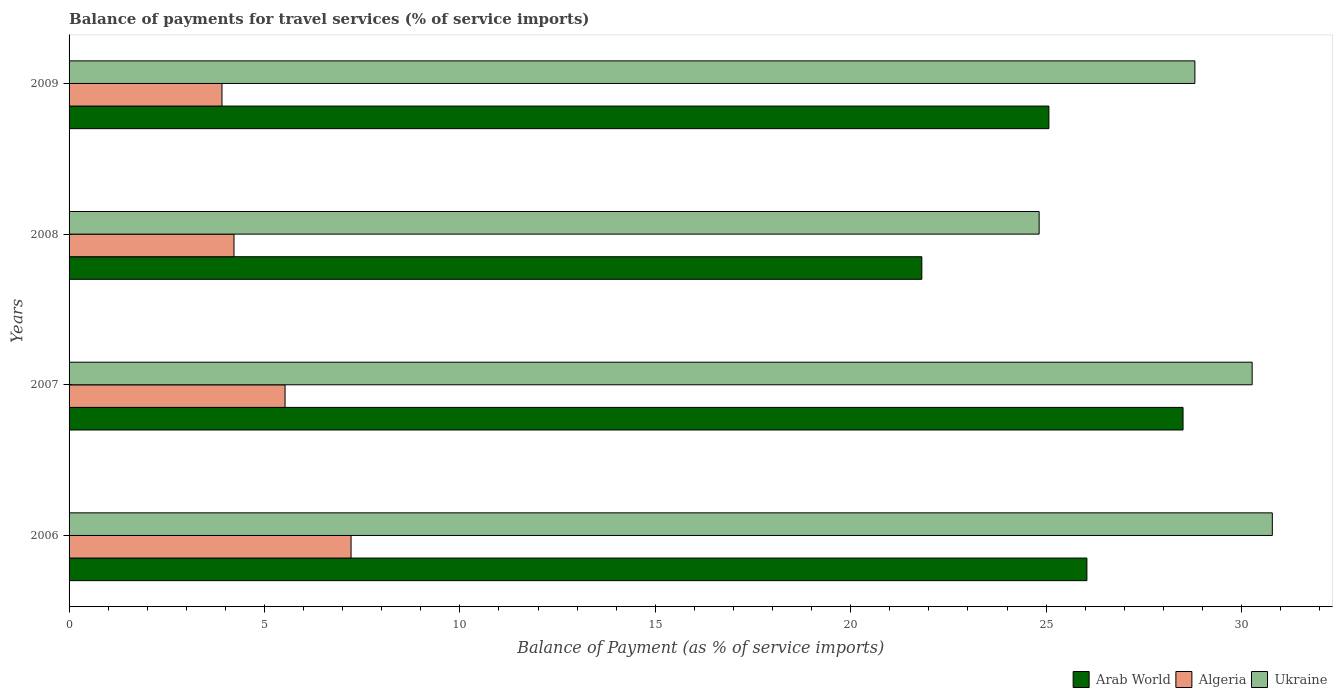How many different coloured bars are there?
Give a very brief answer. 3. How many groups of bars are there?
Provide a short and direct response. 4. Are the number of bars per tick equal to the number of legend labels?
Keep it short and to the point. Yes. How many bars are there on the 2nd tick from the top?
Provide a succinct answer. 3. How many bars are there on the 4th tick from the bottom?
Provide a succinct answer. 3. What is the label of the 2nd group of bars from the top?
Provide a short and direct response. 2008. In how many cases, is the number of bars for a given year not equal to the number of legend labels?
Keep it short and to the point. 0. What is the balance of payments for travel services in Ukraine in 2009?
Make the answer very short. 28.81. Across all years, what is the maximum balance of payments for travel services in Ukraine?
Give a very brief answer. 30.79. Across all years, what is the minimum balance of payments for travel services in Algeria?
Offer a very short reply. 3.91. In which year was the balance of payments for travel services in Algeria minimum?
Offer a very short reply. 2009. What is the total balance of payments for travel services in Ukraine in the graph?
Your answer should be very brief. 114.69. What is the difference between the balance of payments for travel services in Algeria in 2008 and that in 2009?
Your answer should be compact. 0.31. What is the difference between the balance of payments for travel services in Ukraine in 2009 and the balance of payments for travel services in Algeria in 2008?
Make the answer very short. 24.59. What is the average balance of payments for travel services in Ukraine per year?
Ensure brevity in your answer.  28.67. In the year 2006, what is the difference between the balance of payments for travel services in Ukraine and balance of payments for travel services in Arab World?
Offer a terse response. 4.74. What is the ratio of the balance of payments for travel services in Arab World in 2006 to that in 2007?
Provide a succinct answer. 0.91. Is the balance of payments for travel services in Ukraine in 2007 less than that in 2009?
Provide a succinct answer. No. What is the difference between the highest and the second highest balance of payments for travel services in Arab World?
Offer a very short reply. 2.46. What is the difference between the highest and the lowest balance of payments for travel services in Ukraine?
Offer a very short reply. 5.97. What does the 1st bar from the top in 2006 represents?
Your response must be concise. Ukraine. What does the 1st bar from the bottom in 2009 represents?
Your answer should be very brief. Arab World. Is it the case that in every year, the sum of the balance of payments for travel services in Arab World and balance of payments for travel services in Algeria is greater than the balance of payments for travel services in Ukraine?
Keep it short and to the point. Yes. How many bars are there?
Keep it short and to the point. 12. Are all the bars in the graph horizontal?
Ensure brevity in your answer.  Yes. Are the values on the major ticks of X-axis written in scientific E-notation?
Make the answer very short. No. Does the graph contain any zero values?
Your answer should be very brief. No. Does the graph contain grids?
Provide a succinct answer. No. Where does the legend appear in the graph?
Your answer should be compact. Bottom right. How many legend labels are there?
Offer a very short reply. 3. How are the legend labels stacked?
Provide a short and direct response. Horizontal. What is the title of the graph?
Make the answer very short. Balance of payments for travel services (% of service imports). What is the label or title of the X-axis?
Provide a succinct answer. Balance of Payment (as % of service imports). What is the Balance of Payment (as % of service imports) in Arab World in 2006?
Make the answer very short. 26.04. What is the Balance of Payment (as % of service imports) in Algeria in 2006?
Offer a very short reply. 7.22. What is the Balance of Payment (as % of service imports) of Ukraine in 2006?
Offer a very short reply. 30.79. What is the Balance of Payment (as % of service imports) of Arab World in 2007?
Your answer should be very brief. 28.5. What is the Balance of Payment (as % of service imports) in Algeria in 2007?
Make the answer very short. 5.53. What is the Balance of Payment (as % of service imports) in Ukraine in 2007?
Ensure brevity in your answer.  30.27. What is the Balance of Payment (as % of service imports) in Arab World in 2008?
Ensure brevity in your answer.  21.82. What is the Balance of Payment (as % of service imports) in Algeria in 2008?
Provide a short and direct response. 4.22. What is the Balance of Payment (as % of service imports) of Ukraine in 2008?
Provide a succinct answer. 24.82. What is the Balance of Payment (as % of service imports) in Arab World in 2009?
Ensure brevity in your answer.  25.07. What is the Balance of Payment (as % of service imports) in Algeria in 2009?
Your answer should be compact. 3.91. What is the Balance of Payment (as % of service imports) in Ukraine in 2009?
Give a very brief answer. 28.81. Across all years, what is the maximum Balance of Payment (as % of service imports) of Arab World?
Keep it short and to the point. 28.5. Across all years, what is the maximum Balance of Payment (as % of service imports) of Algeria?
Your response must be concise. 7.22. Across all years, what is the maximum Balance of Payment (as % of service imports) of Ukraine?
Ensure brevity in your answer.  30.79. Across all years, what is the minimum Balance of Payment (as % of service imports) in Arab World?
Offer a terse response. 21.82. Across all years, what is the minimum Balance of Payment (as % of service imports) in Algeria?
Your answer should be compact. 3.91. Across all years, what is the minimum Balance of Payment (as % of service imports) in Ukraine?
Your answer should be compact. 24.82. What is the total Balance of Payment (as % of service imports) of Arab World in the graph?
Keep it short and to the point. 101.44. What is the total Balance of Payment (as % of service imports) in Algeria in the graph?
Provide a short and direct response. 20.87. What is the total Balance of Payment (as % of service imports) in Ukraine in the graph?
Give a very brief answer. 114.69. What is the difference between the Balance of Payment (as % of service imports) in Arab World in 2006 and that in 2007?
Your answer should be compact. -2.46. What is the difference between the Balance of Payment (as % of service imports) of Algeria in 2006 and that in 2007?
Make the answer very short. 1.69. What is the difference between the Balance of Payment (as % of service imports) in Ukraine in 2006 and that in 2007?
Your answer should be compact. 0.52. What is the difference between the Balance of Payment (as % of service imports) of Arab World in 2006 and that in 2008?
Ensure brevity in your answer.  4.22. What is the difference between the Balance of Payment (as % of service imports) in Algeria in 2006 and that in 2008?
Provide a short and direct response. 3. What is the difference between the Balance of Payment (as % of service imports) of Ukraine in 2006 and that in 2008?
Offer a terse response. 5.97. What is the difference between the Balance of Payment (as % of service imports) of Arab World in 2006 and that in 2009?
Make the answer very short. 0.97. What is the difference between the Balance of Payment (as % of service imports) in Algeria in 2006 and that in 2009?
Your response must be concise. 3.3. What is the difference between the Balance of Payment (as % of service imports) in Ukraine in 2006 and that in 2009?
Provide a short and direct response. 1.98. What is the difference between the Balance of Payment (as % of service imports) of Arab World in 2007 and that in 2008?
Your answer should be very brief. 6.68. What is the difference between the Balance of Payment (as % of service imports) of Algeria in 2007 and that in 2008?
Ensure brevity in your answer.  1.31. What is the difference between the Balance of Payment (as % of service imports) of Ukraine in 2007 and that in 2008?
Give a very brief answer. 5.45. What is the difference between the Balance of Payment (as % of service imports) in Arab World in 2007 and that in 2009?
Offer a very short reply. 3.43. What is the difference between the Balance of Payment (as % of service imports) of Algeria in 2007 and that in 2009?
Offer a very short reply. 1.61. What is the difference between the Balance of Payment (as % of service imports) of Ukraine in 2007 and that in 2009?
Your answer should be very brief. 1.47. What is the difference between the Balance of Payment (as % of service imports) in Arab World in 2008 and that in 2009?
Offer a very short reply. -3.25. What is the difference between the Balance of Payment (as % of service imports) in Algeria in 2008 and that in 2009?
Make the answer very short. 0.31. What is the difference between the Balance of Payment (as % of service imports) in Ukraine in 2008 and that in 2009?
Give a very brief answer. -3.99. What is the difference between the Balance of Payment (as % of service imports) in Arab World in 2006 and the Balance of Payment (as % of service imports) in Algeria in 2007?
Offer a terse response. 20.52. What is the difference between the Balance of Payment (as % of service imports) of Arab World in 2006 and the Balance of Payment (as % of service imports) of Ukraine in 2007?
Offer a very short reply. -4.23. What is the difference between the Balance of Payment (as % of service imports) in Algeria in 2006 and the Balance of Payment (as % of service imports) in Ukraine in 2007?
Your response must be concise. -23.06. What is the difference between the Balance of Payment (as % of service imports) of Arab World in 2006 and the Balance of Payment (as % of service imports) of Algeria in 2008?
Ensure brevity in your answer.  21.82. What is the difference between the Balance of Payment (as % of service imports) of Arab World in 2006 and the Balance of Payment (as % of service imports) of Ukraine in 2008?
Offer a terse response. 1.22. What is the difference between the Balance of Payment (as % of service imports) in Algeria in 2006 and the Balance of Payment (as % of service imports) in Ukraine in 2008?
Give a very brief answer. -17.61. What is the difference between the Balance of Payment (as % of service imports) of Arab World in 2006 and the Balance of Payment (as % of service imports) of Algeria in 2009?
Offer a very short reply. 22.13. What is the difference between the Balance of Payment (as % of service imports) of Arab World in 2006 and the Balance of Payment (as % of service imports) of Ukraine in 2009?
Your answer should be compact. -2.76. What is the difference between the Balance of Payment (as % of service imports) of Algeria in 2006 and the Balance of Payment (as % of service imports) of Ukraine in 2009?
Keep it short and to the point. -21.59. What is the difference between the Balance of Payment (as % of service imports) in Arab World in 2007 and the Balance of Payment (as % of service imports) in Algeria in 2008?
Provide a short and direct response. 24.28. What is the difference between the Balance of Payment (as % of service imports) in Arab World in 2007 and the Balance of Payment (as % of service imports) in Ukraine in 2008?
Offer a very short reply. 3.68. What is the difference between the Balance of Payment (as % of service imports) of Algeria in 2007 and the Balance of Payment (as % of service imports) of Ukraine in 2008?
Your response must be concise. -19.29. What is the difference between the Balance of Payment (as % of service imports) of Arab World in 2007 and the Balance of Payment (as % of service imports) of Algeria in 2009?
Offer a very short reply. 24.59. What is the difference between the Balance of Payment (as % of service imports) in Arab World in 2007 and the Balance of Payment (as % of service imports) in Ukraine in 2009?
Ensure brevity in your answer.  -0.3. What is the difference between the Balance of Payment (as % of service imports) in Algeria in 2007 and the Balance of Payment (as % of service imports) in Ukraine in 2009?
Offer a very short reply. -23.28. What is the difference between the Balance of Payment (as % of service imports) of Arab World in 2008 and the Balance of Payment (as % of service imports) of Algeria in 2009?
Keep it short and to the point. 17.91. What is the difference between the Balance of Payment (as % of service imports) in Arab World in 2008 and the Balance of Payment (as % of service imports) in Ukraine in 2009?
Offer a very short reply. -6.99. What is the difference between the Balance of Payment (as % of service imports) in Algeria in 2008 and the Balance of Payment (as % of service imports) in Ukraine in 2009?
Offer a terse response. -24.59. What is the average Balance of Payment (as % of service imports) of Arab World per year?
Make the answer very short. 25.36. What is the average Balance of Payment (as % of service imports) of Algeria per year?
Give a very brief answer. 5.22. What is the average Balance of Payment (as % of service imports) in Ukraine per year?
Your answer should be compact. 28.67. In the year 2006, what is the difference between the Balance of Payment (as % of service imports) of Arab World and Balance of Payment (as % of service imports) of Algeria?
Your answer should be very brief. 18.83. In the year 2006, what is the difference between the Balance of Payment (as % of service imports) in Arab World and Balance of Payment (as % of service imports) in Ukraine?
Provide a short and direct response. -4.74. In the year 2006, what is the difference between the Balance of Payment (as % of service imports) in Algeria and Balance of Payment (as % of service imports) in Ukraine?
Offer a very short reply. -23.57. In the year 2007, what is the difference between the Balance of Payment (as % of service imports) of Arab World and Balance of Payment (as % of service imports) of Algeria?
Keep it short and to the point. 22.98. In the year 2007, what is the difference between the Balance of Payment (as % of service imports) in Arab World and Balance of Payment (as % of service imports) in Ukraine?
Provide a short and direct response. -1.77. In the year 2007, what is the difference between the Balance of Payment (as % of service imports) of Algeria and Balance of Payment (as % of service imports) of Ukraine?
Your answer should be very brief. -24.75. In the year 2008, what is the difference between the Balance of Payment (as % of service imports) in Arab World and Balance of Payment (as % of service imports) in Algeria?
Keep it short and to the point. 17.6. In the year 2008, what is the difference between the Balance of Payment (as % of service imports) of Arab World and Balance of Payment (as % of service imports) of Ukraine?
Your answer should be compact. -3. In the year 2008, what is the difference between the Balance of Payment (as % of service imports) in Algeria and Balance of Payment (as % of service imports) in Ukraine?
Offer a very short reply. -20.6. In the year 2009, what is the difference between the Balance of Payment (as % of service imports) of Arab World and Balance of Payment (as % of service imports) of Algeria?
Provide a short and direct response. 21.16. In the year 2009, what is the difference between the Balance of Payment (as % of service imports) in Arab World and Balance of Payment (as % of service imports) in Ukraine?
Keep it short and to the point. -3.74. In the year 2009, what is the difference between the Balance of Payment (as % of service imports) of Algeria and Balance of Payment (as % of service imports) of Ukraine?
Offer a terse response. -24.89. What is the ratio of the Balance of Payment (as % of service imports) of Arab World in 2006 to that in 2007?
Ensure brevity in your answer.  0.91. What is the ratio of the Balance of Payment (as % of service imports) in Algeria in 2006 to that in 2007?
Your answer should be very brief. 1.31. What is the ratio of the Balance of Payment (as % of service imports) of Ukraine in 2006 to that in 2007?
Offer a very short reply. 1.02. What is the ratio of the Balance of Payment (as % of service imports) in Arab World in 2006 to that in 2008?
Your response must be concise. 1.19. What is the ratio of the Balance of Payment (as % of service imports) in Algeria in 2006 to that in 2008?
Make the answer very short. 1.71. What is the ratio of the Balance of Payment (as % of service imports) of Ukraine in 2006 to that in 2008?
Give a very brief answer. 1.24. What is the ratio of the Balance of Payment (as % of service imports) in Arab World in 2006 to that in 2009?
Give a very brief answer. 1.04. What is the ratio of the Balance of Payment (as % of service imports) of Algeria in 2006 to that in 2009?
Your answer should be very brief. 1.84. What is the ratio of the Balance of Payment (as % of service imports) of Ukraine in 2006 to that in 2009?
Provide a succinct answer. 1.07. What is the ratio of the Balance of Payment (as % of service imports) of Arab World in 2007 to that in 2008?
Make the answer very short. 1.31. What is the ratio of the Balance of Payment (as % of service imports) of Algeria in 2007 to that in 2008?
Ensure brevity in your answer.  1.31. What is the ratio of the Balance of Payment (as % of service imports) of Ukraine in 2007 to that in 2008?
Offer a terse response. 1.22. What is the ratio of the Balance of Payment (as % of service imports) of Arab World in 2007 to that in 2009?
Make the answer very short. 1.14. What is the ratio of the Balance of Payment (as % of service imports) of Algeria in 2007 to that in 2009?
Make the answer very short. 1.41. What is the ratio of the Balance of Payment (as % of service imports) in Ukraine in 2007 to that in 2009?
Ensure brevity in your answer.  1.05. What is the ratio of the Balance of Payment (as % of service imports) in Arab World in 2008 to that in 2009?
Ensure brevity in your answer.  0.87. What is the ratio of the Balance of Payment (as % of service imports) of Algeria in 2008 to that in 2009?
Offer a terse response. 1.08. What is the ratio of the Balance of Payment (as % of service imports) of Ukraine in 2008 to that in 2009?
Ensure brevity in your answer.  0.86. What is the difference between the highest and the second highest Balance of Payment (as % of service imports) in Arab World?
Your answer should be compact. 2.46. What is the difference between the highest and the second highest Balance of Payment (as % of service imports) of Algeria?
Provide a succinct answer. 1.69. What is the difference between the highest and the second highest Balance of Payment (as % of service imports) in Ukraine?
Offer a terse response. 0.52. What is the difference between the highest and the lowest Balance of Payment (as % of service imports) in Arab World?
Offer a very short reply. 6.68. What is the difference between the highest and the lowest Balance of Payment (as % of service imports) of Algeria?
Your answer should be compact. 3.3. What is the difference between the highest and the lowest Balance of Payment (as % of service imports) in Ukraine?
Provide a short and direct response. 5.97. 